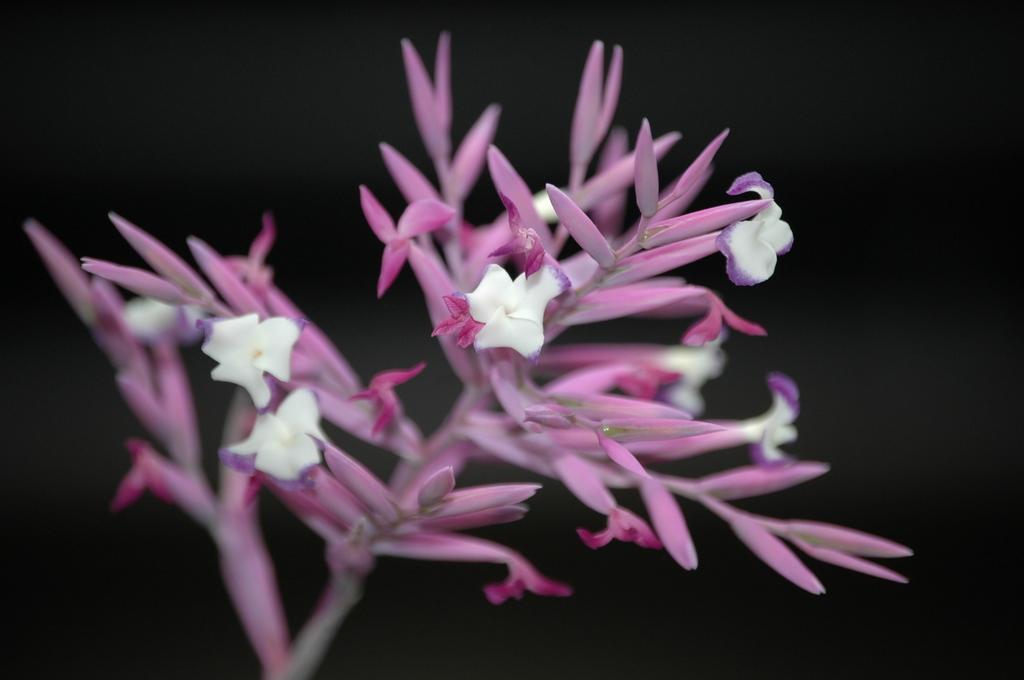Can you describe this image briefly? In the image we can see some flowers and plant. 